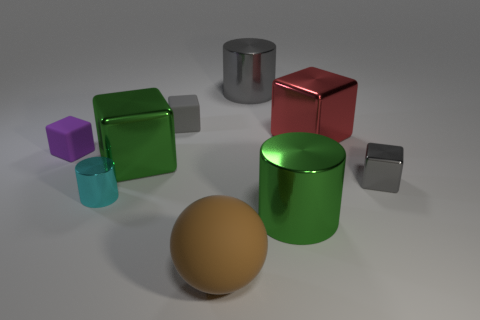Subtract all brown cylinders. How many gray blocks are left? 2 Subtract all tiny blocks. How many blocks are left? 2 Add 1 red metallic blocks. How many objects exist? 10 Subtract all gray cubes. How many cubes are left? 3 Subtract 2 gray blocks. How many objects are left? 7 Subtract all spheres. How many objects are left? 8 Subtract all green blocks. Subtract all gray balls. How many blocks are left? 4 Subtract all red things. Subtract all gray matte things. How many objects are left? 7 Add 2 gray rubber blocks. How many gray rubber blocks are left? 3 Add 2 small gray metal things. How many small gray metal things exist? 3 